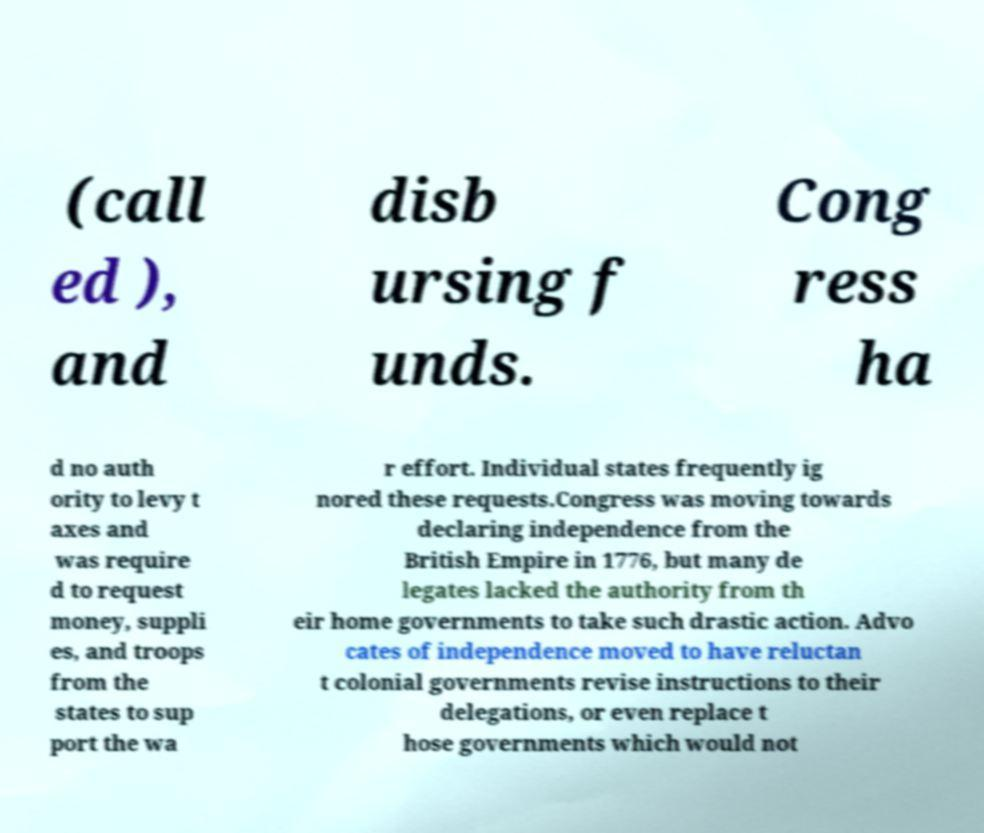Can you accurately transcribe the text from the provided image for me? (call ed ), and disb ursing f unds. Cong ress ha d no auth ority to levy t axes and was require d to request money, suppli es, and troops from the states to sup port the wa r effort. Individual states frequently ig nored these requests.Congress was moving towards declaring independence from the British Empire in 1776, but many de legates lacked the authority from th eir home governments to take such drastic action. Advo cates of independence moved to have reluctan t colonial governments revise instructions to their delegations, or even replace t hose governments which would not 